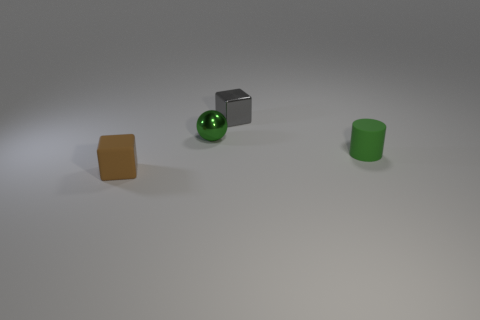Add 3 green cylinders. How many objects exist? 7 Subtract all spheres. How many objects are left? 3 Subtract all small balls. Subtract all tiny shiny things. How many objects are left? 1 Add 3 brown blocks. How many brown blocks are left? 4 Add 3 tiny red balls. How many tiny red balls exist? 3 Subtract 0 yellow cylinders. How many objects are left? 4 